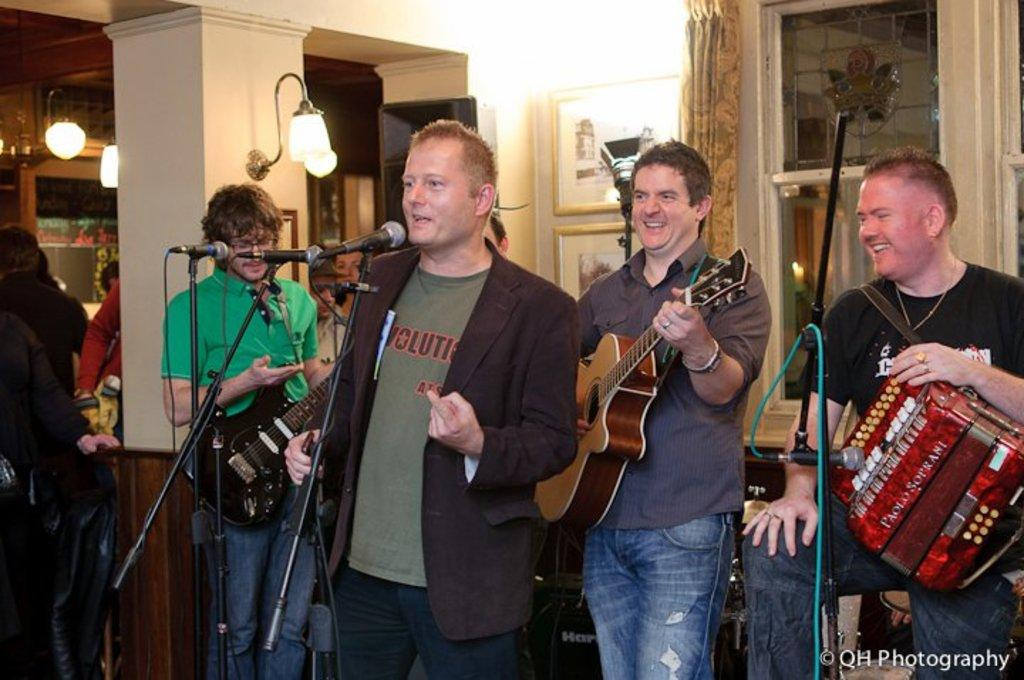How many men are in the image? There are multiple men in the image. What are the men doing in the image? The men are standing in the image. What objects are the men holding in their hands? Some people are holding guitars in their hands. Are there any other musical instruments present besides guitars? Yes, there is at least one other musical instrument present. Can you tell me where the aunt is standing in the image? There is no aunt present in the image. What type of angle is being used to capture the image? The angle of the image cannot be determined from the image itself. 